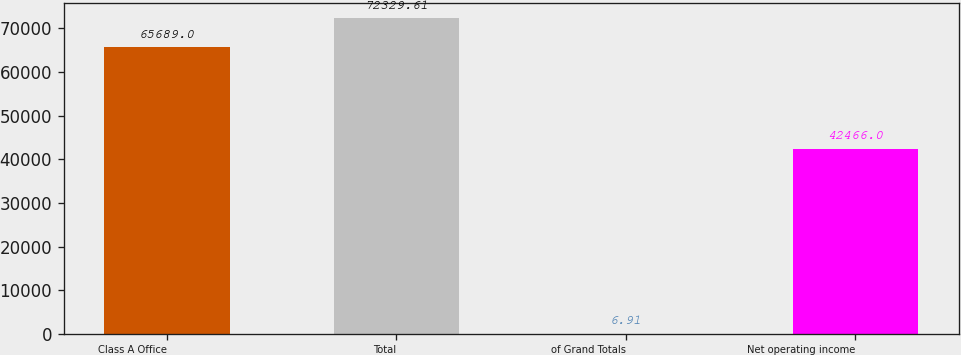<chart> <loc_0><loc_0><loc_500><loc_500><bar_chart><fcel>Class A Office<fcel>Total<fcel>of Grand Totals<fcel>Net operating income<nl><fcel>65689<fcel>72329.6<fcel>6.91<fcel>42466<nl></chart> 